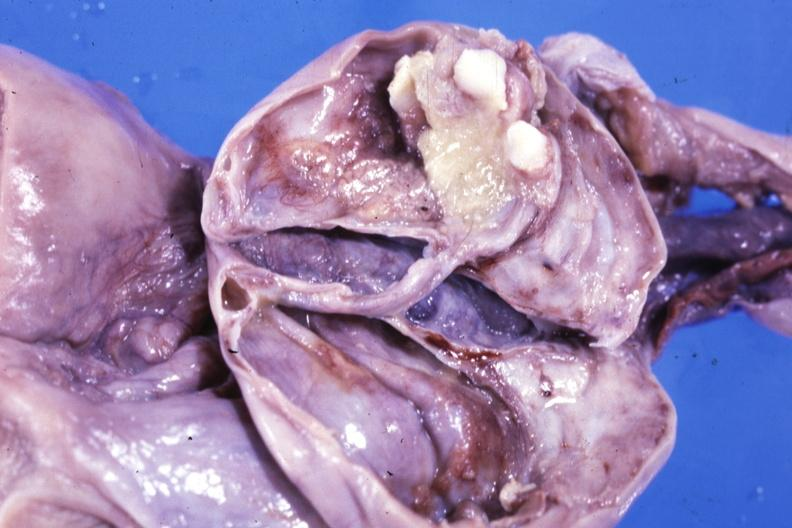s fixed tissue opened ovarian cyst with two or three teeth?
Answer the question using a single word or phrase. Yes 